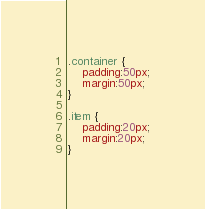Convert code to text. <code><loc_0><loc_0><loc_500><loc_500><_CSS_>.container {
    padding:50px;
    margin:50px;
}

.item {
    padding:20px;
    margin:20px;
}</code> 